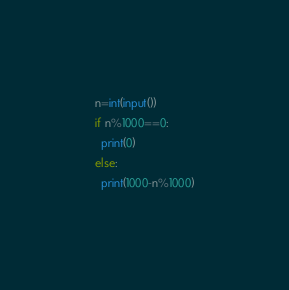Convert code to text. <code><loc_0><loc_0><loc_500><loc_500><_Python_>n=int(input())
if n%1000==0:
  print(0)
else:
  print(1000-n%1000)</code> 